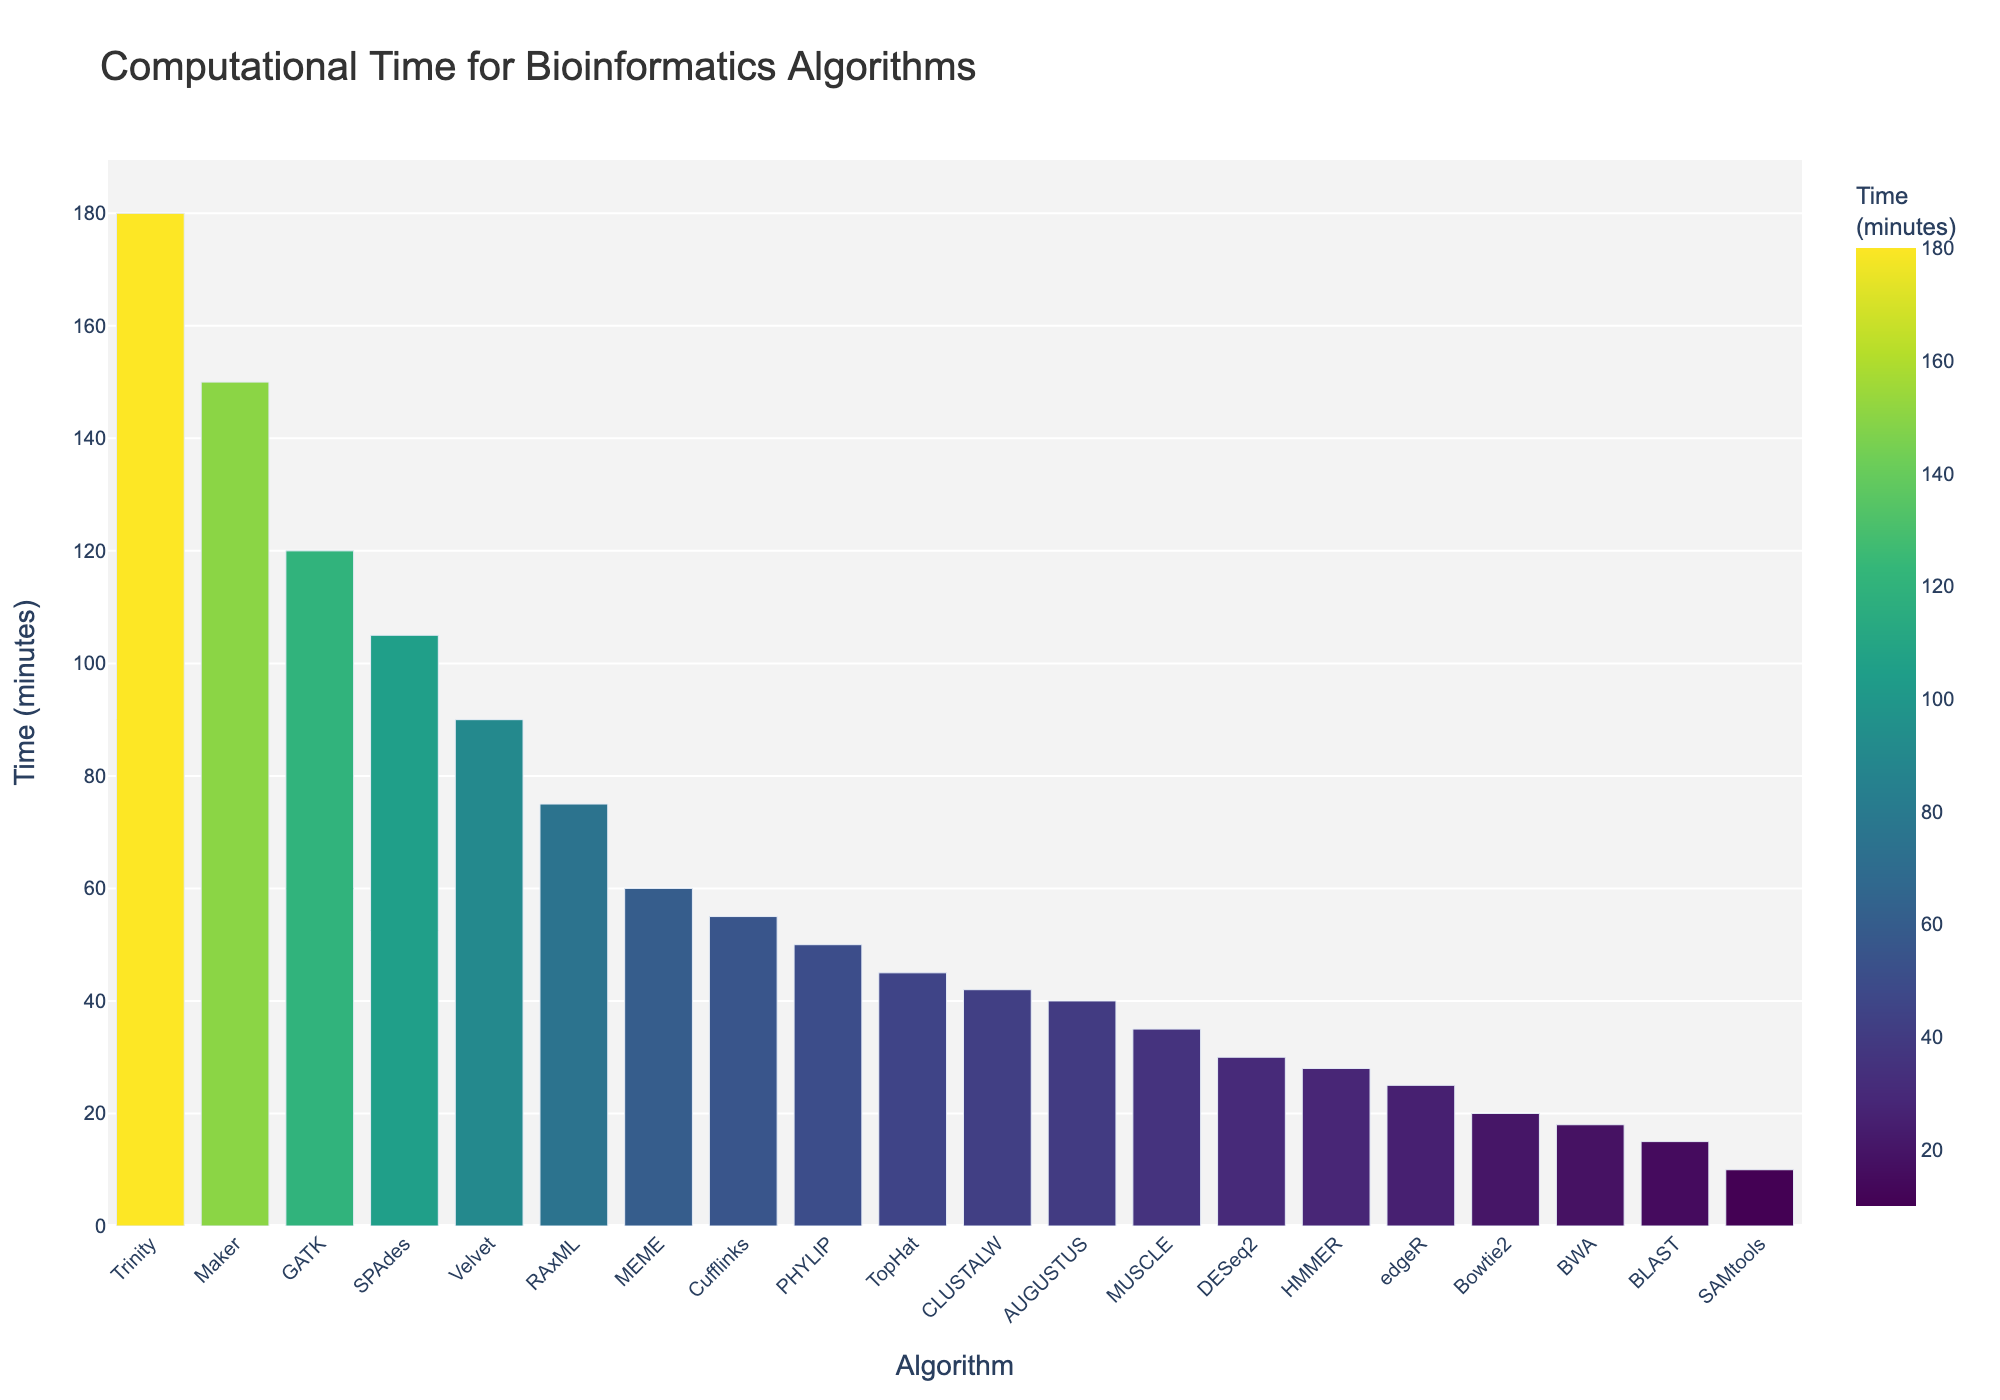What's the algorithm with the highest computational time? The algorithm with the highest computational time is determined by identifying the tallest bar in the chart. The bar representing Trinity is the highest.
Answer: Trinity Which algorithm has the lowest computational time? The algorithm with the lowest computational time is represented by the shortest bar in the chart. The shortest bar corresponds to SAMtools.
Answer: SAMtools What is the total computational time for BLAST, GATK, and Bowtie2? The sum of the computational times for these algorithms involves adding their individual times: BLAST (15 minutes) + GATK (120 minutes) + Bowtie2 (20 minutes) = 155 minutes.
Answer: 155 minutes How much longer does Trinity take compared to SAMtools? The computational time for Trinity is 180 minutes, and for SAMtools it is 10 minutes. The difference is calculated as 180 - 10 = 170 minutes.
Answer: 170 minutes Which algorithms take more than an hour to run? Algorithms taking more than an hour have bars indicating computational times greater than 60 minutes. These include Velvet, SPAdes, Maker, and Trinity.
Answer: Velvet, SPAdes, Maker, Trinity What is the average computational time of MEME, MUSCLE, and PHYLIP? The average is calculated by summing their times and dividing by the number of algorithms: (MEME (60) + MUSCLE (35) + PHYLIP (50)) / 3 = 145 / 3 ≈ 48.33 minutes.
Answer: 48.33 minutes How many algorithms have a computational time less than 30 minutes? By observing the chart, algorithms with bars indicating less than 30 minutes are BLAST, Bowtie2, SAMtools, BWA, and edgeR. Counting these gives a total of 5 algorithms.
Answer: 5 Compare the computational times of CLUSTALW and AUGUSTUS. Which one is faster, and by how many minutes? CLUSTALW takes 42 minutes, and AUGUSTUS takes 40 minutes. AUGUSTUS is faster by 42 - 40 = 2 minutes.
Answer: AUGUSTUS, 2 minutes What is the color indicating the shortest computational time and which algorithm does it represent? The shortest computational time is indicated by the lightest shade in the color scale. This color corresponds to the SAMtools algorithm.
Answer: Light shade, SAMtools Which algorithm just takes slightly more computational time than PHYLIP? The computational time for PHYLIP is 50 minutes. The algorithm with a slightly higher time is Cufflinks with 55 minutes.
Answer: Cufflinks 